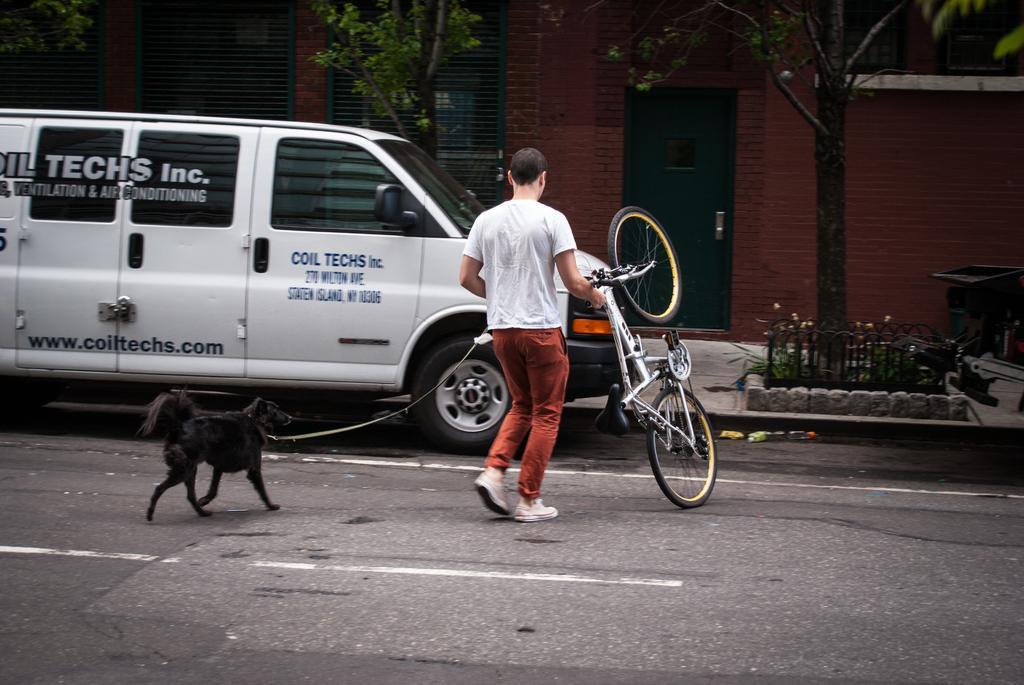Could you give a brief overview of what you see in this image? In this image we can see a person and a dog walking on the road, there is a vehicle parked beside the road, there are trees, plants and a trash bin in front of the building. 